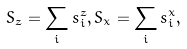Convert formula to latex. <formula><loc_0><loc_0><loc_500><loc_500>S _ { z } = \sum _ { i } s _ { i } ^ { z } , S _ { x } = \sum _ { i } s _ { i } ^ { x } ,</formula> 